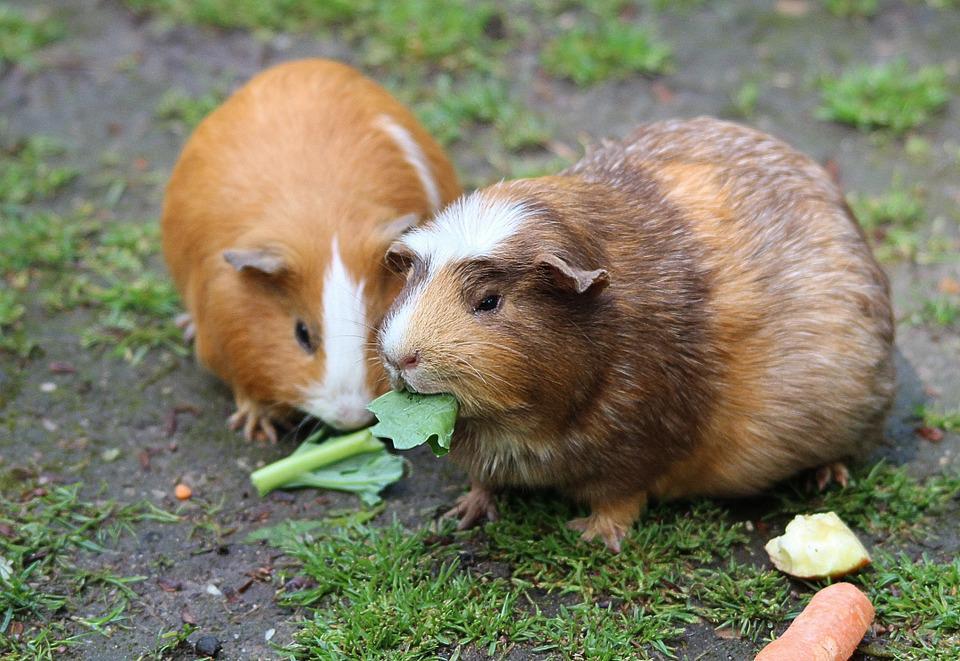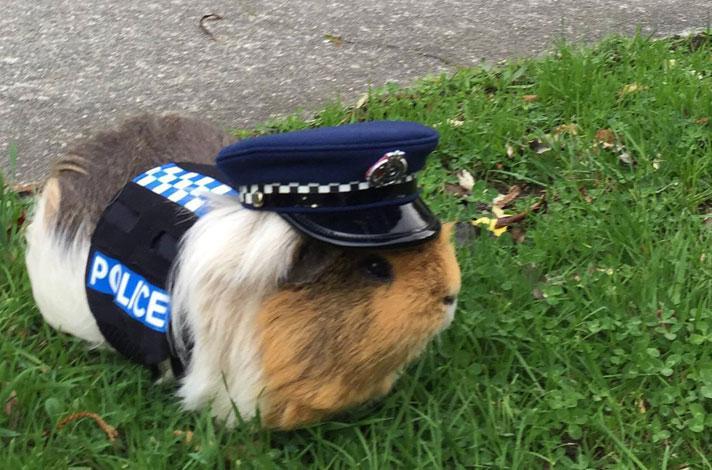The first image is the image on the left, the second image is the image on the right. Assess this claim about the two images: "Three gerbils are in a grassy outdoor area, one alone wearing a costume, while two of different colors are together.". Correct or not? Answer yes or no. Yes. The first image is the image on the left, the second image is the image on the right. Analyze the images presented: Is the assertion "An image shows a pet rodent dressed in a uniform vest costume." valid? Answer yes or no. Yes. 